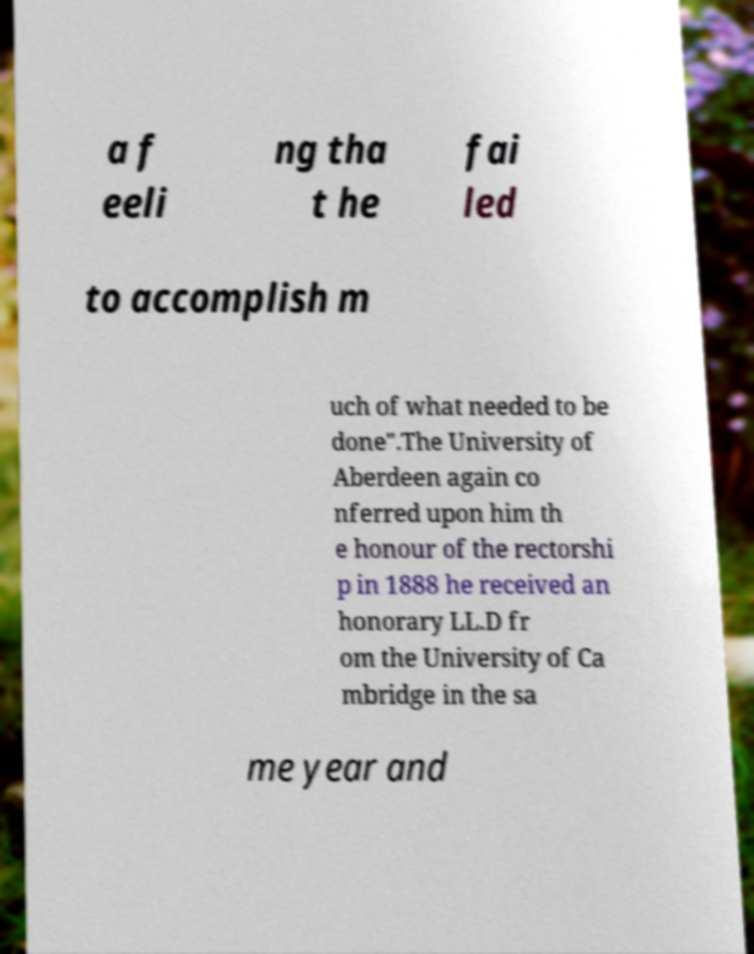Please read and relay the text visible in this image. What does it say? a f eeli ng tha t he fai led to accomplish m uch of what needed to be done".The University of Aberdeen again co nferred upon him th e honour of the rectorshi p in 1888 he received an honorary LL.D fr om the University of Ca mbridge in the sa me year and 